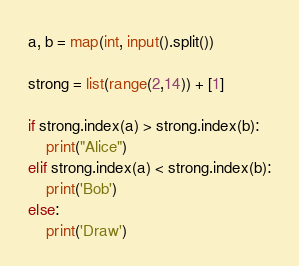<code> <loc_0><loc_0><loc_500><loc_500><_Python_>a, b = map(int, input().split())

strong = list(range(2,14)) + [1]

if strong.index(a) > strong.index(b):
    print("Alice")
elif strong.index(a) < strong.index(b):
    print('Bob')
else:
    print('Draw')</code> 